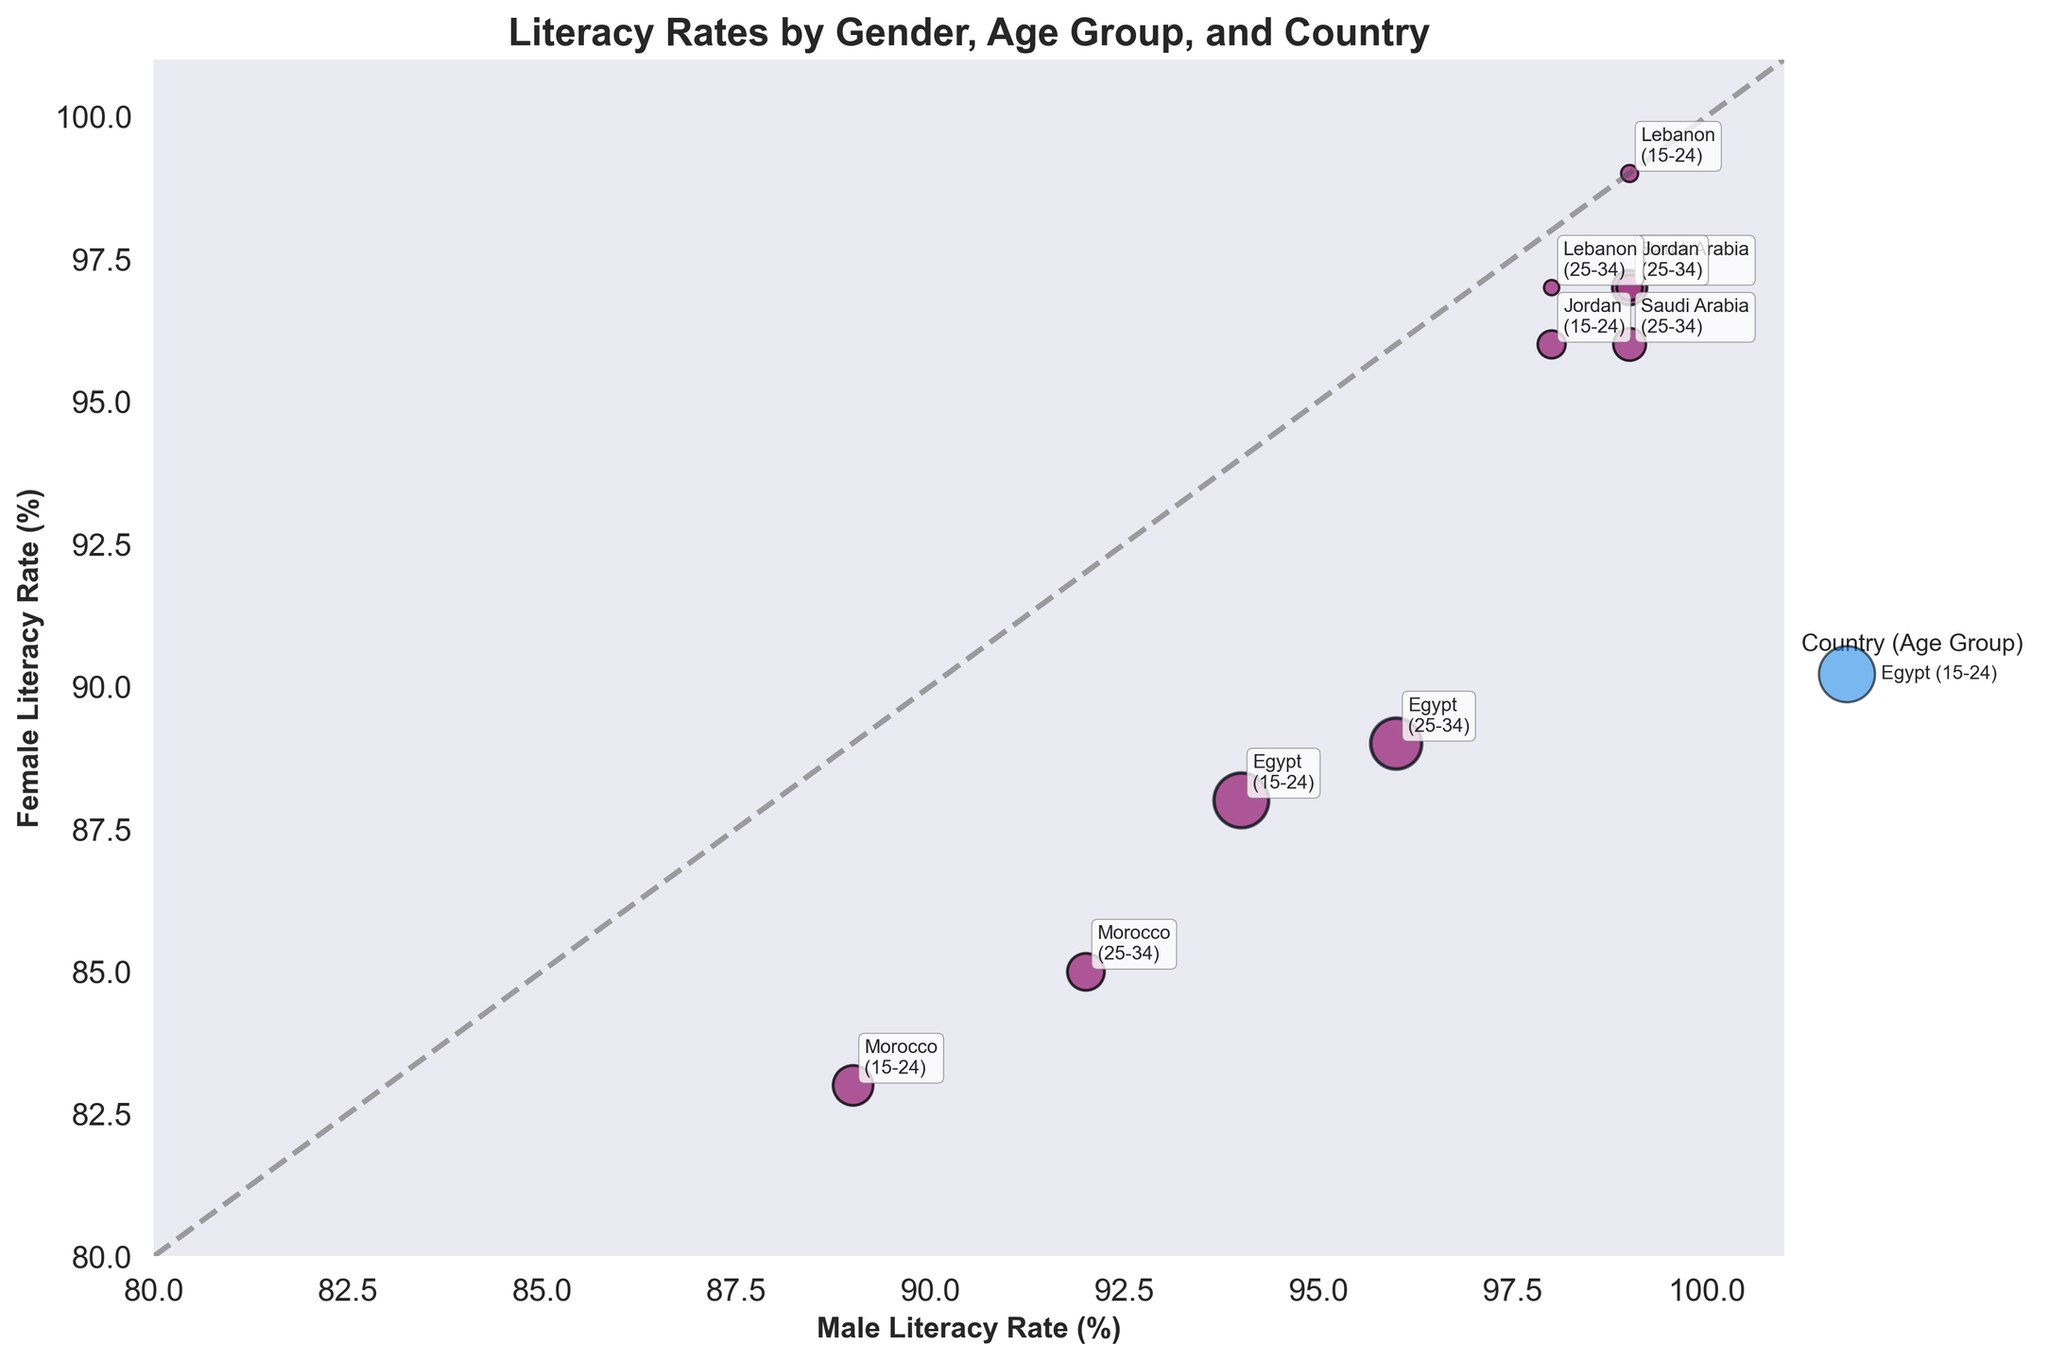What's the title of the figure? The title of a figure is typically located at the top and gives a brief description of what the figure is about. In this case, the title is "Literacy Rates by Gender, Age Group, and Country."
Answer: Literacy Rates by Gender, Age Group, and Country What are the x and y-axis labels on the chart? Axis labels help identify what the scales represent. Here, the x-axis label is "Male Literacy Rate (%)", and the y-axis label is "Female Literacy Rate (%)".
Answer: Male Literacy Rate (%), Female Literacy Rate (%) Which country has the highest male literacy rate for the 15-24 age group? To determine this, we look at the x-axis values for the 15-24 age group. Saudi Arabia and Lebanon both reach the highest value of 99%.
Answer: Saudi Arabia and Lebanon What is the population size of Egyptian females aged 25-34? We look at the size of the bubble representing Egyptian females aged 25-34. The female population is given as 4.3 million in the data, reflected in the bubble size.
Answer: 4.3 million For the age group 15-24, which country shows the closest male and female literacy rates? Look where the bubble for each country lies closest to the diagonal line y=x (where literacy rates for males and females would be equal). Lebanon shows both male and female literacy rates at 99%.
Answer: Lebanon How does the literacy rate of Moroccan males aged 25-34 compare to that of Moroccan females aged 25-34? For Morocco in the age group 25-34, the male literacy rate is 92%, and the female literacy rate is 85%. Subtracting these percentages shows males have a 7% higher literacy rate.
Answer: 7% higher Which country and age group combination has the lowest female literacy rate? By finding the smallest y-axis value for female literacy rates, we see that Moroccan females aged 15-24 have the lowest rate at 83%.
Answer: Moroccan females aged 15-24 What is the average female literacy rate for Jordan across both age groups? To find the average, add the female literacy rates for Jordan in both age groups (15-24 and 25-34) and divide by 2. That's (96 + 97) / 2 = 96.5%.
Answer: 96.5% Are there any countries where male and female literacy rates are equal in any age group? Look for bubbles that lie along the y=x line. Lebanon shows equal literacy rates for both males and females aged 15-24 at 99%.
Answer: Lebanon (15-24) 